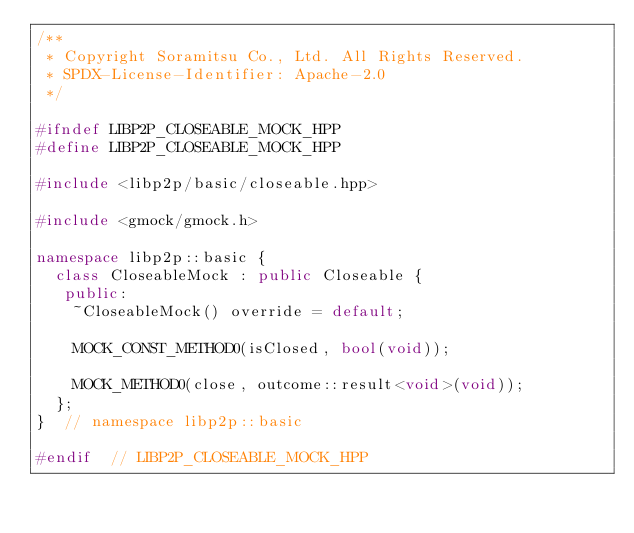<code> <loc_0><loc_0><loc_500><loc_500><_C++_>/**
 * Copyright Soramitsu Co., Ltd. All Rights Reserved.
 * SPDX-License-Identifier: Apache-2.0
 */

#ifndef LIBP2P_CLOSEABLE_MOCK_HPP
#define LIBP2P_CLOSEABLE_MOCK_HPP

#include <libp2p/basic/closeable.hpp>

#include <gmock/gmock.h>

namespace libp2p::basic {
  class CloseableMock : public Closeable {
   public:
    ~CloseableMock() override = default;

    MOCK_CONST_METHOD0(isClosed, bool(void));

    MOCK_METHOD0(close, outcome::result<void>(void));
  };
}  // namespace libp2p::basic

#endif  // LIBP2P_CLOSEABLE_MOCK_HPP
</code> 